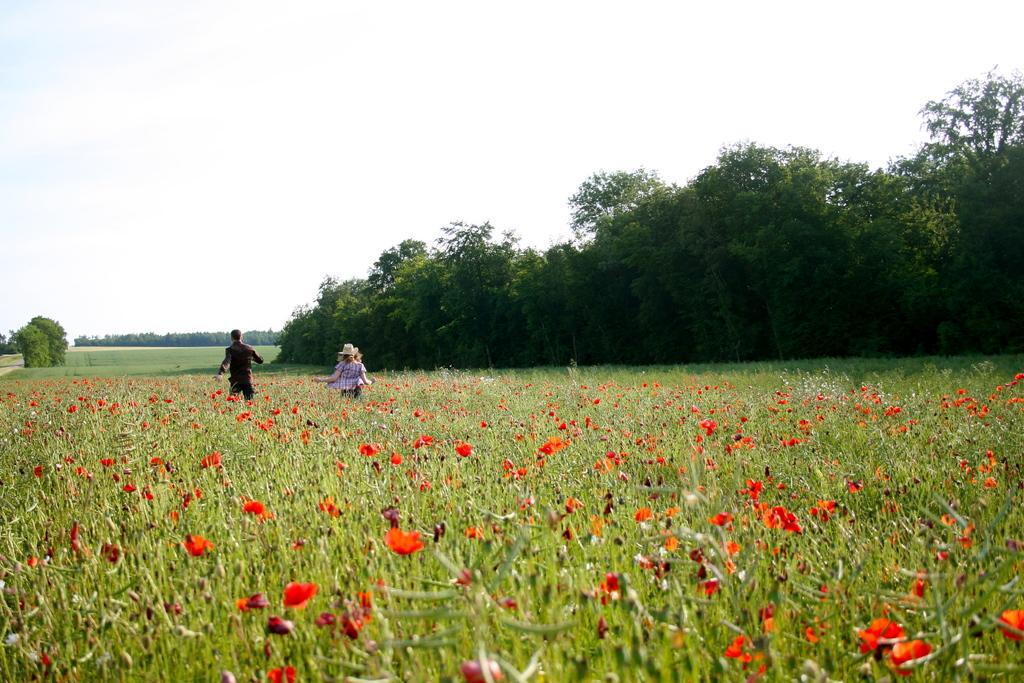How many people are present in the image? There are two persons in the image. What types of plants can be seen in the image? There are plants, flowers, trees, and grass visible in the image. What is visible in the background of the image? The sky is visible in the background of the image, along with trees and grass. What type of bells can be heard ringing in the image? There are no bells present in the image, and therefore no sound can be heard. 